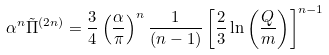<formula> <loc_0><loc_0><loc_500><loc_500>\alpha ^ { n } \tilde { \Pi } ^ { ( 2 n ) } = \frac { 3 } { 4 } \left ( \frac { \alpha } { \pi } \right ) ^ { n } \frac { 1 } { ( n - 1 ) } \left [ \frac { 2 } { 3 } \ln \left ( \frac { Q } { m } \right ) \right ] ^ { n - 1 }</formula> 